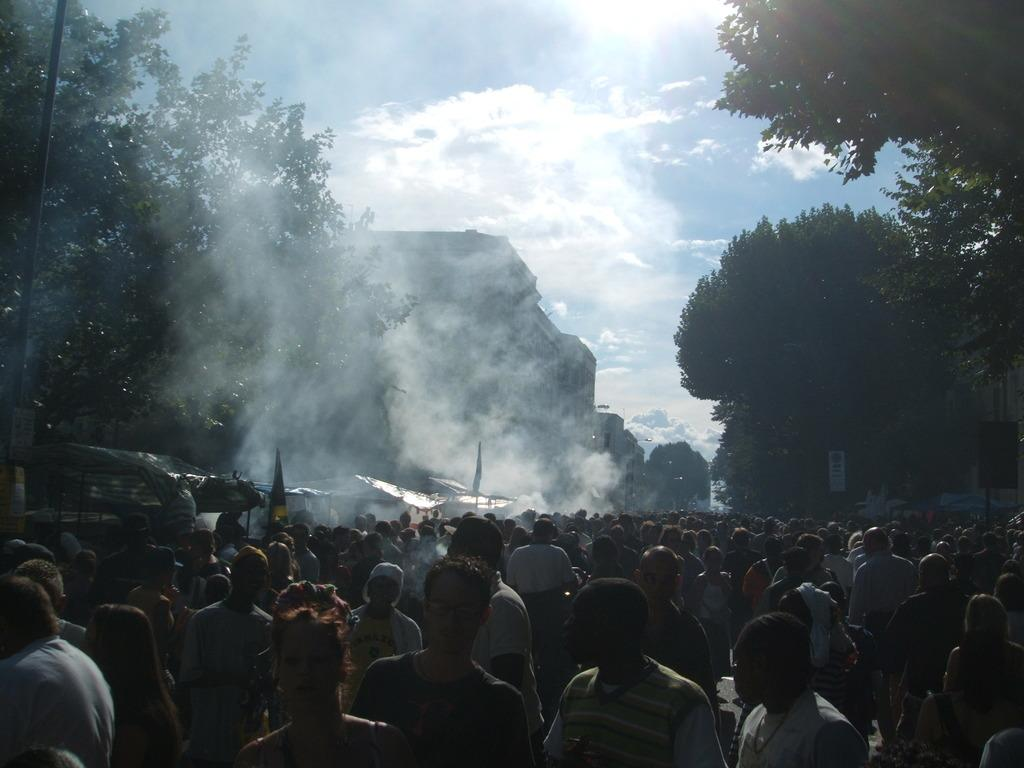Who or what can be seen in the image? There are people in the image. What type of structures are visible in the image? There are buildings, sheds, and a pole in the image. What natural elements are present in the image? There are trees and clouds visible in the image. What additional objects can be seen in the image? There are flags, a board, and plastic spoons visible in the image. What is visible in the background of the image? The sky is visible in the image, with clouds present. Can you see anyone wearing a vest in the image? There is no mention of a vest in the image, so it cannot be determined if anyone is wearing one. Are there any socks visible in the image? There is no mention of socks in the image, so it cannot be determined if any are visible. 